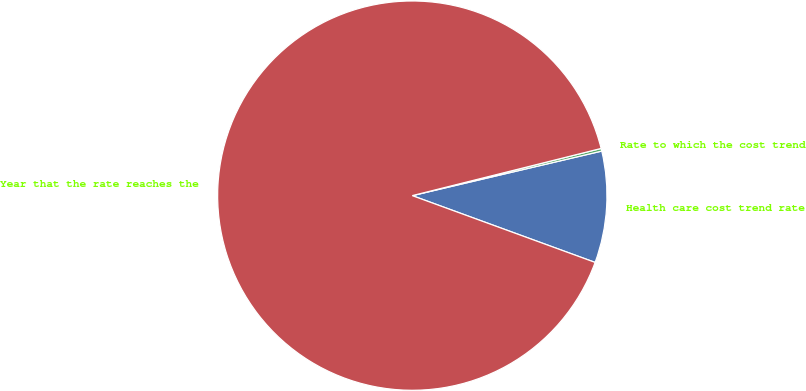<chart> <loc_0><loc_0><loc_500><loc_500><pie_chart><fcel>Health care cost trend rate<fcel>Rate to which the cost trend<fcel>Year that the rate reaches the<nl><fcel>9.25%<fcel>0.22%<fcel>90.52%<nl></chart> 